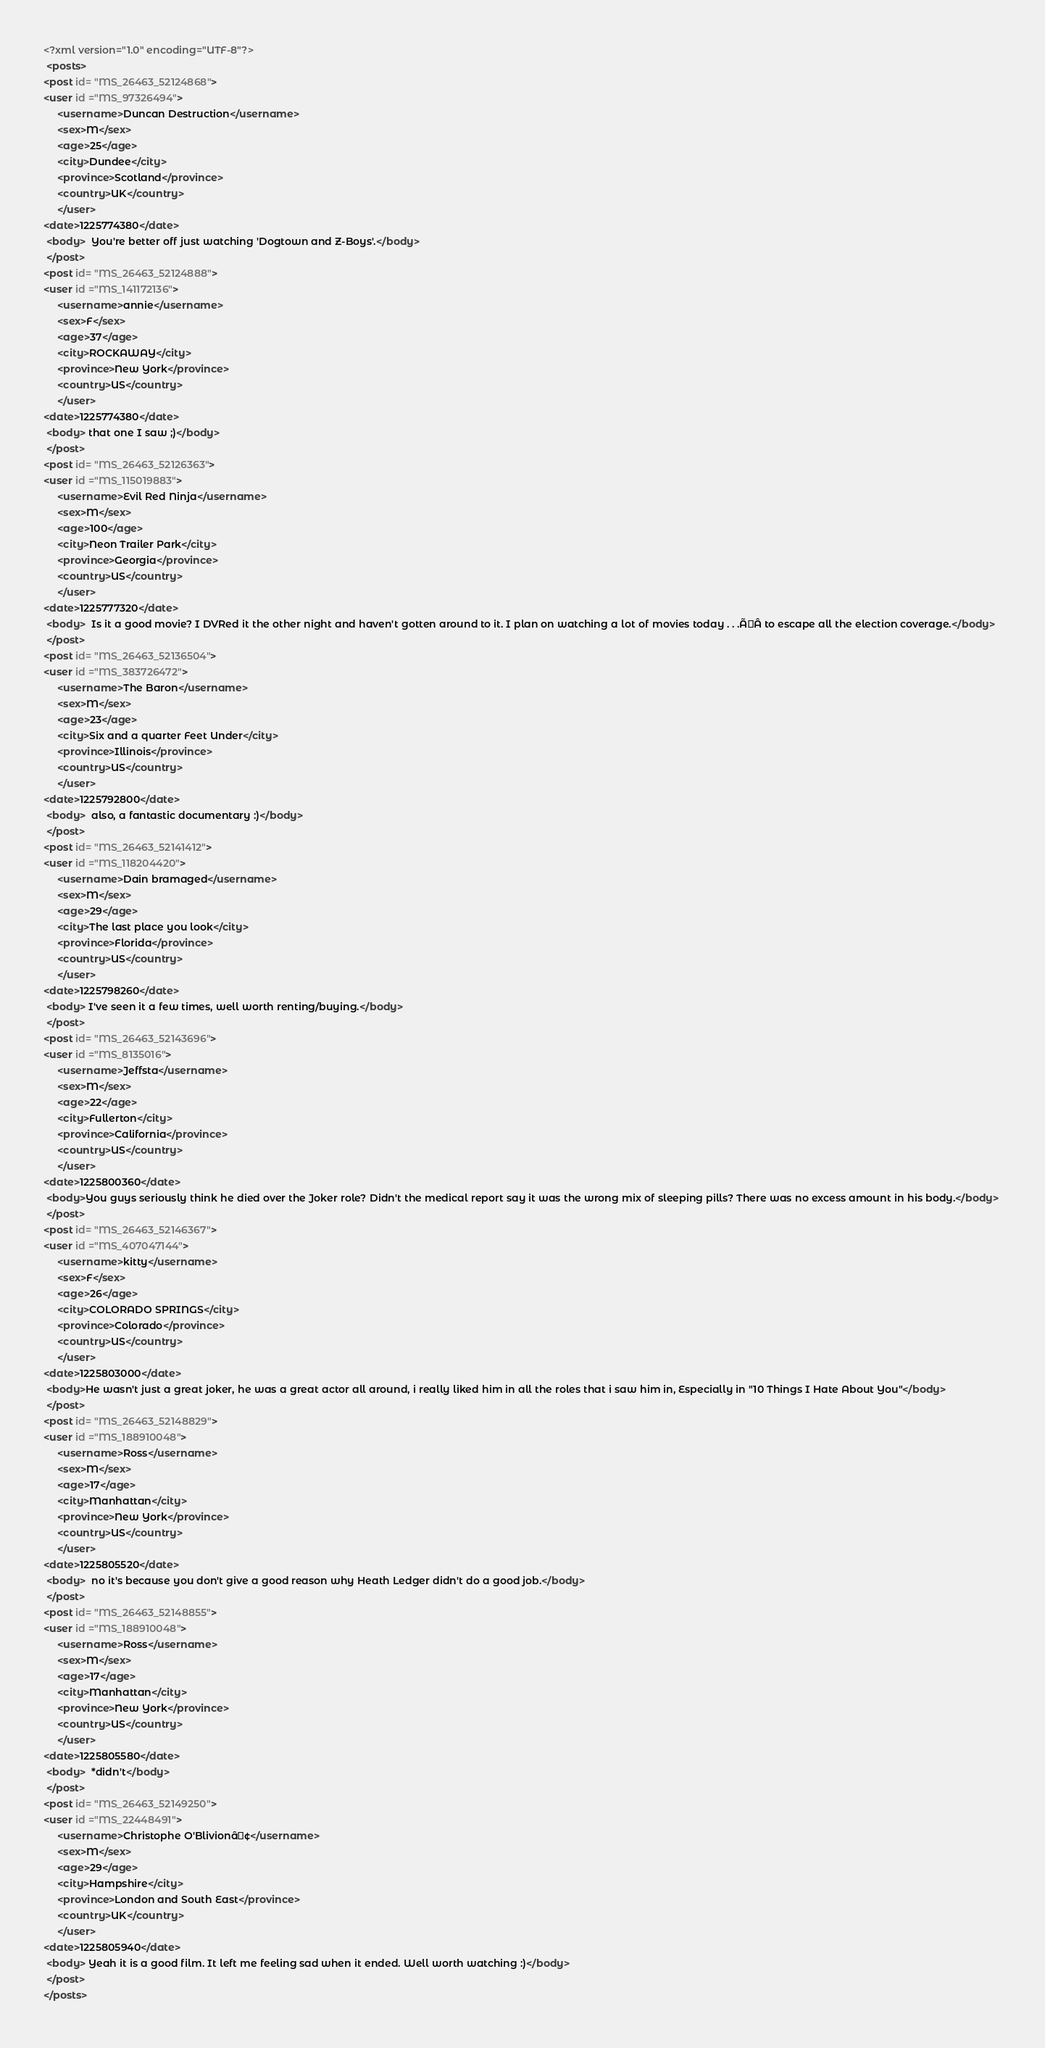Convert code to text. <code><loc_0><loc_0><loc_500><loc_500><_XML_><?xml version="1.0" encoding="UTF-8"?> 
 <posts> 
<post id= "MS_26463_52124868"> 
<user id ="MS_97326494"> 
	 <username>Duncan Destruction</username> 
	 <sex>M</sex> 
	 <age>25</age> 
	 <city>Dundee</city> 
	 <province>Scotland</province> 
	 <country>UK</country> 
	 </user> 
<date>1225774380</date> 
 <body>  You're better off just watching 'Dogtown and Z-Boys'.</body> 
 </post> 
<post id= "MS_26463_52124888"> 
<user id ="MS_141172136"> 
	 <username>annie</username> 
	 <sex>F</sex> 
	 <age>37</age> 
	 <city>ROCKAWAY</city> 
	 <province>New York</province> 
	 <country>US</country> 
	 </user> 
<date>1225774380</date> 
 <body> that one I saw ;)</body> 
 </post> 
<post id= "MS_26463_52126363"> 
<user id ="MS_115019883"> 
	 <username>Evil Red Ninja</username> 
	 <sex>M</sex> 
	 <age>100</age> 
	 <city>Neon Trailer Park</city> 
	 <province>Georgia</province> 
	 <country>US</country> 
	 </user> 
<date>1225777320</date> 
 <body>  Is it a good movie? I DVRed it the other night and haven't gotten around to it. I plan on watching a lot of movies today . . .ÃÂ to escape all the election coverage.</body> 
 </post> 
<post id= "MS_26463_52136504"> 
<user id ="MS_383726472"> 
	 <username>The Baron</username> 
	 <sex>M</sex> 
	 <age>23</age> 
	 <city>Six and a quarter Feet Under</city> 
	 <province>Illinois</province> 
	 <country>US</country> 
	 </user> 
<date>1225792800</date> 
 <body>  also, a fantastic documentary :)</body> 
 </post> 
<post id= "MS_26463_52141412"> 
<user id ="MS_118204420"> 
	 <username>Dain bramaged</username> 
	 <sex>M</sex> 
	 <age>29</age> 
	 <city>The last place you look</city> 
	 <province>Florida</province> 
	 <country>US</country> 
	 </user> 
<date>1225798260</date> 
 <body> I've seen it a few times, well worth renting/buying.</body> 
 </post> 
<post id= "MS_26463_52143696"> 
<user id ="MS_8135016"> 
	 <username>Jeffsta</username> 
	 <sex>M</sex> 
	 <age>22</age> 
	 <city>Fullerton</city> 
	 <province>California</province> 
	 <country>US</country> 
	 </user> 
<date>1225800360</date> 
 <body>You guys seriously think he died over the Joker role? Didn't the medical report say it was the wrong mix of sleeping pills? There was no excess amount in his body.</body> 
 </post> 
<post id= "MS_26463_52146367"> 
<user id ="MS_407047144"> 
	 <username>kitty</username> 
	 <sex>F</sex> 
	 <age>26</age> 
	 <city>COLORADO SPRINGS</city> 
	 <province>Colorado</province> 
	 <country>US</country> 
	 </user> 
<date>1225803000</date> 
 <body>He wasn't just a great joker, he was a great actor all around, i really liked him in all the roles that i saw him in, Especially in "10 Things I Hate About You"</body> 
 </post> 
<post id= "MS_26463_52148829"> 
<user id ="MS_188910048"> 
	 <username>Ross</username> 
	 <sex>M</sex> 
	 <age>17</age> 
	 <city>Manhattan</city> 
	 <province>New York</province> 
	 <country>US</country> 
	 </user> 
<date>1225805520</date> 
 <body>  no it's because you don't give a good reason why Heath Ledger didn't do a good job.</body> 
 </post> 
<post id= "MS_26463_52148855"> 
<user id ="MS_188910048"> 
	 <username>Ross</username> 
	 <sex>M</sex> 
	 <age>17</age> 
	 <city>Manhattan</city> 
	 <province>New York</province> 
	 <country>US</country> 
	 </user> 
<date>1225805580</date> 
 <body>  *didn't</body> 
 </post> 
<post id= "MS_26463_52149250"> 
<user id ="MS_22448491"> 
	 <username>Christophe O'Blivionâ¢</username> 
	 <sex>M</sex> 
	 <age>29</age> 
	 <city>Hampshire</city> 
	 <province>London and South East</province> 
	 <country>UK</country> 
	 </user> 
<date>1225805940</date> 
 <body> Yeah it is a good film. It left me feeling sad when it ended. Well worth watching :)</body> 
 </post> 
</posts></code> 